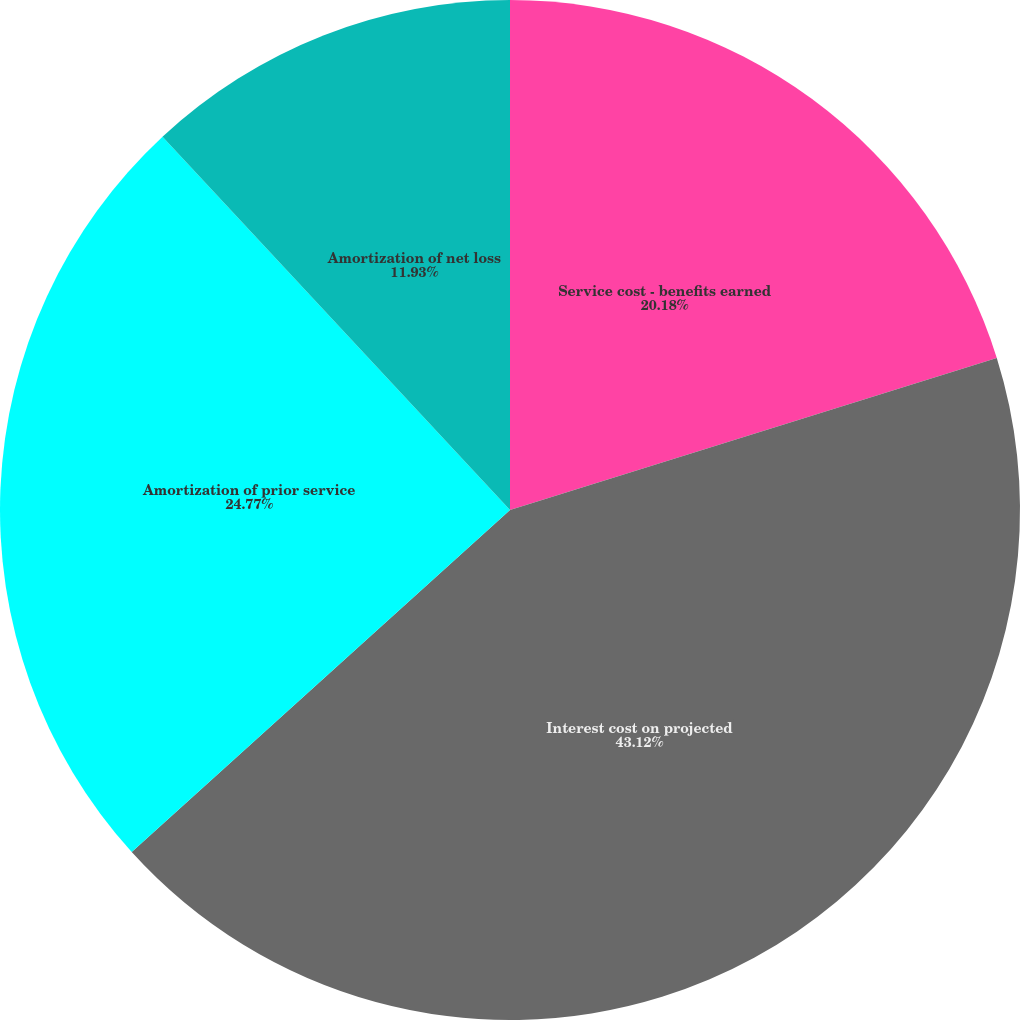Convert chart. <chart><loc_0><loc_0><loc_500><loc_500><pie_chart><fcel>Service cost - benefits earned<fcel>Interest cost on projected<fcel>Amortization of prior service<fcel>Amortization of net loss<nl><fcel>20.18%<fcel>43.12%<fcel>24.77%<fcel>11.93%<nl></chart> 